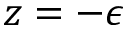<formula> <loc_0><loc_0><loc_500><loc_500>z = - \epsilon</formula> 